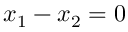Convert formula to latex. <formula><loc_0><loc_0><loc_500><loc_500>x _ { 1 } - x _ { 2 } = 0</formula> 